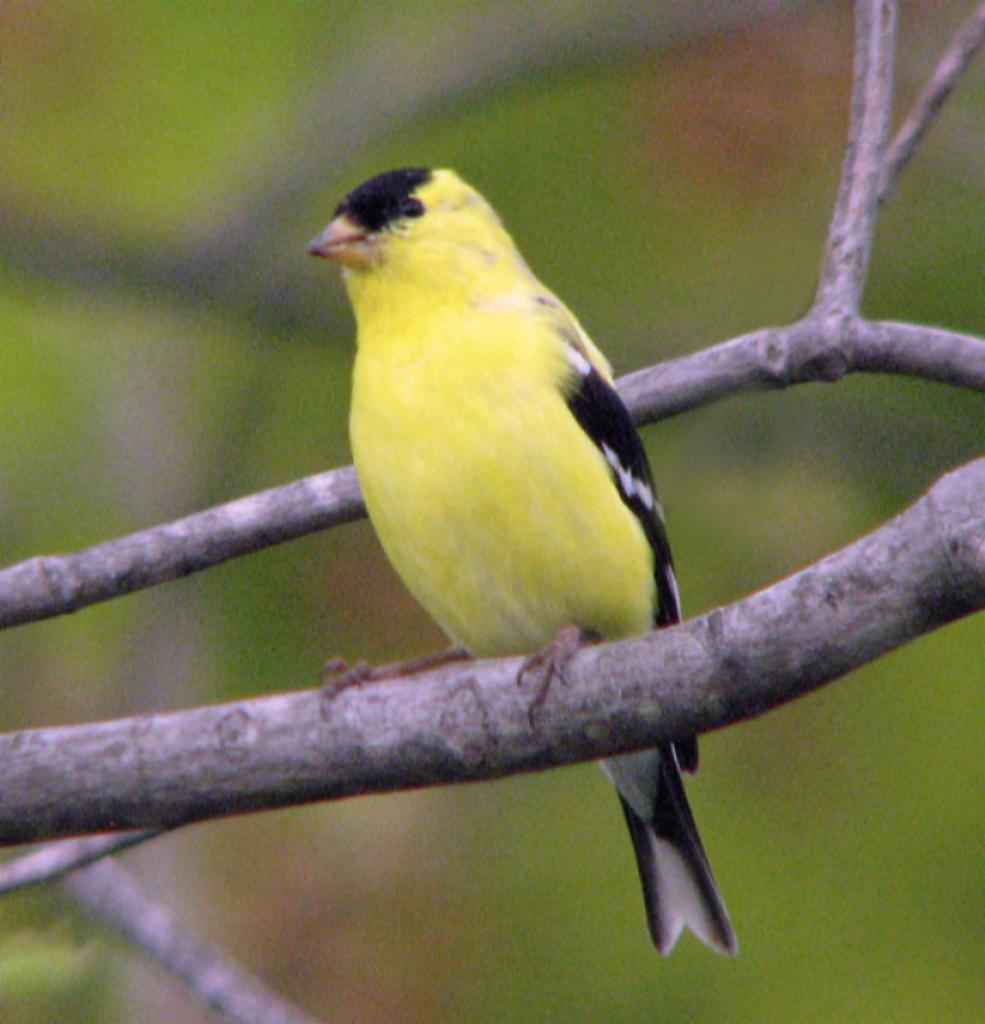What type of animal can be seen in the image? There is a bird in the image. Where is the bird located? The bird is sitting on a branch of a tree. How is the background of the branch depicted? The background of the branch is blurred. What type of industry can be seen in the background of the image? There is no industry present in the image; it features a bird sitting on a branch with a blurred background. 